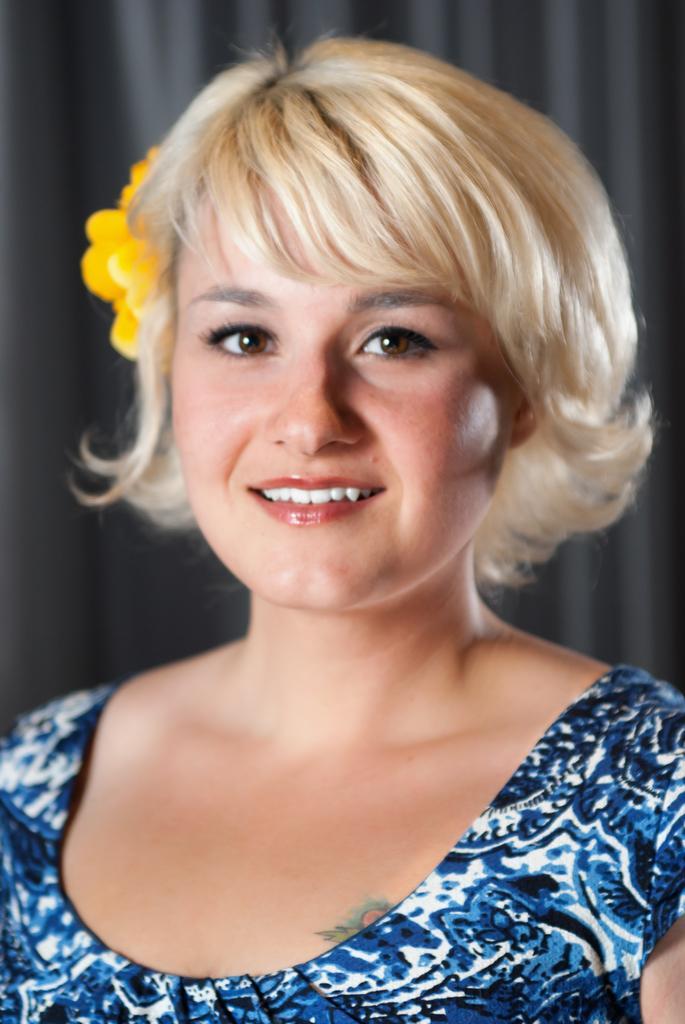Could you give a brief overview of what you see in this image? In this image we can see a lady, she has a flower in her hair, behind her we can see a curtain, and the background is blurred. 